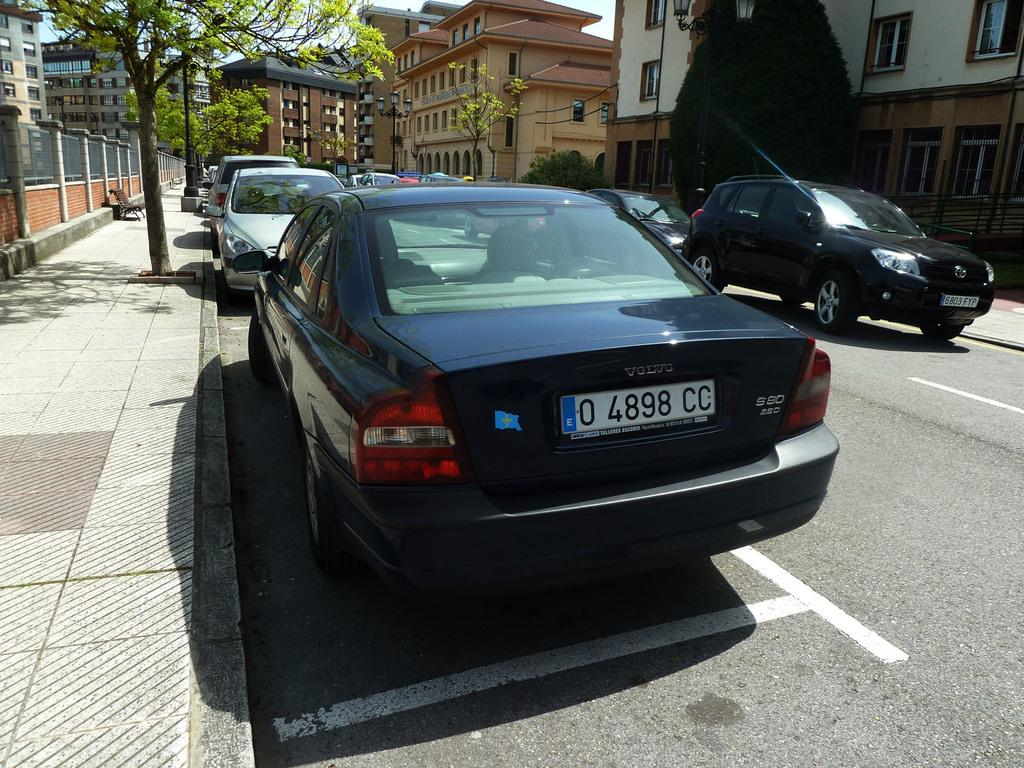<image>
Provide a brief description of the given image. A Volvo with the license plate number 0 4898 CC is parked on the side of the street. 